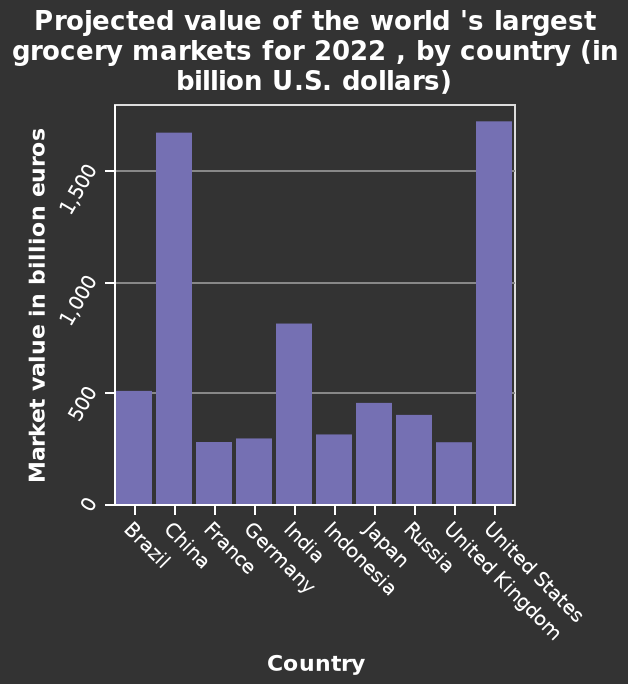<image>
Is the bar diagram representing the current market values of grocery markets? No, the bar diagram represents the projected values of the world's largest grocery markets for 2022. What color are the bars on the graph?  Purple. Which countries have the lowest grocery market?  France, Germany, Indonesia and United Kingdom. 